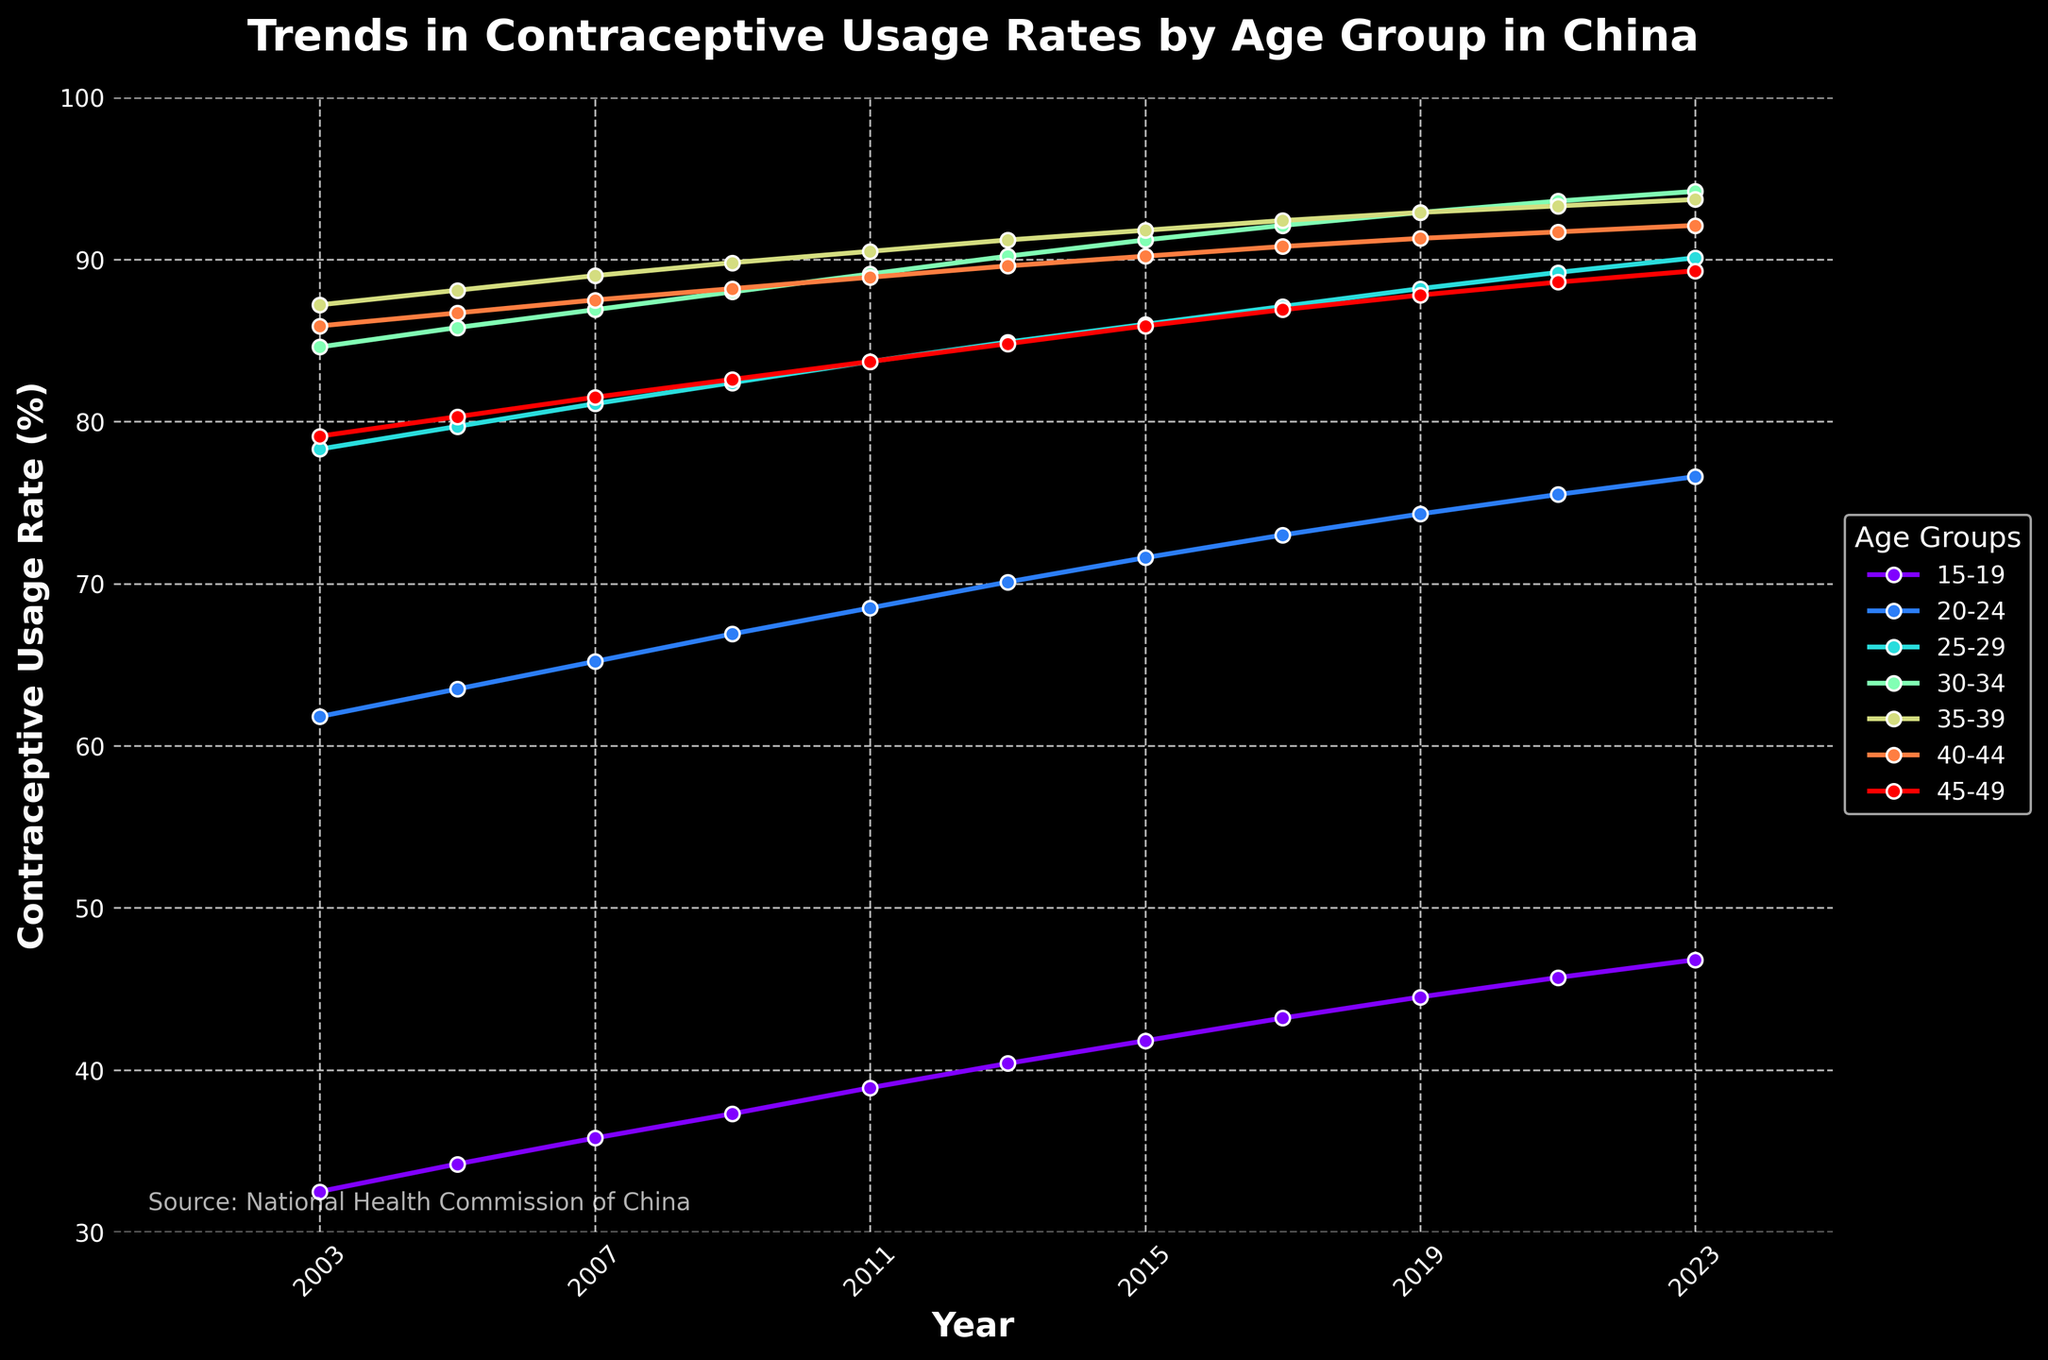Which age group has the highest contraceptive usage rate in 2023? To find the highest contraceptive usage rate in 2023, compare the usage rates of all the age groups listed for that year. The highest value is 94.2 for age group 30-34.
Answer: 30-34 Which age group has shown the most significant increase in contraceptive usage from 2003 to 2023? To determine the most significant increase, subtract the 2003 rate from the 2023 rate for each age group and compare the differences. The differences are: 14.3 (15-19), 14.8 (20-24), 11.8 (25-29), 9.6 (30-34), 6.5 (35-39), 6.2 (40-44), 10.2 (45-49). The highest increase is in the 20-24 age group with 14.8.
Answer: 20-24 What is the average contraceptive usage rate for the 25-29 age group over the years provided? Add the contraceptive usage rates for the 25-29 age group across all years and divide by the number of years. Sum (78.3 + 79.7 + 81.1 + 82.4 + 83.7 + 84.9 + 86.0 + 87.1 + 88.2 + 89.2 + 90.1) is 931.7, divide by 11 gives an average of roughly 84.7.
Answer: 84.7 Between which age groups is the difference in contraceptive usage rates smallest in 2023? Compare the differences in contraceptive usage rates between each pair of age groups in 2023. The smallest difference occurs between the 35-39 and 40-44 age groups, which is 93.7 - 92.1 = 1.6.
Answer: 35-39 and 40-44 In which year did the contraceptive usage rate for the age group 30-34 first exceed 90%? Find the year where the contraceptive usage rate for the 30-34 age group exceeds 90% for the first time. Reviewing the data, it first exceeds 90% in 2013, where it is 90.2.
Answer: 2013 Which age group's contraceptive usage rate exhibits the least fluctuation over the 20 years? Calculate the range (maximum value - minimum value) of contraceptive usage rates for each age group. The smallest range indicates the least fluctuation. The age group with the smallest range is 40-44 with a fluctuation of 92.1 - 85.9 = 6.2.
Answer: 40-44 How many years did it take for the contraceptive usage rate in the 15-19 age group to increase from 34% to over 40%? Identify the years where the contraceptive usage rate for the 15-19 age group exceeds 34% and subsequently exceeds 40%. It starts at 34.2% in 2005 and goes above 40% in 2013. Therefore, it takes 2013 - 2005 = 8 years.
Answer: 8 By how much did the contraceptive usage rate for the 45-49 age group change from 2003 to 2023? Subtract the 2003 contraceptive usage rate from the 2023 rate for the 45-49 age group to find the change. 89.3 - 79.1 = 10.2.
Answer: 10.2 If trends continue, which age group might reach nearly universal contraceptive usage (close to 100%) in the next decade? Observe the highest increasing trends and overall levels, particularly for the 30-34 and 35-39 age groups, both of which are above 90% and approaching 95%. If trends continue, the 30-34 age group, currently at 94.2, is closest to reaching nearly universal usage.
Answer: 30-34 